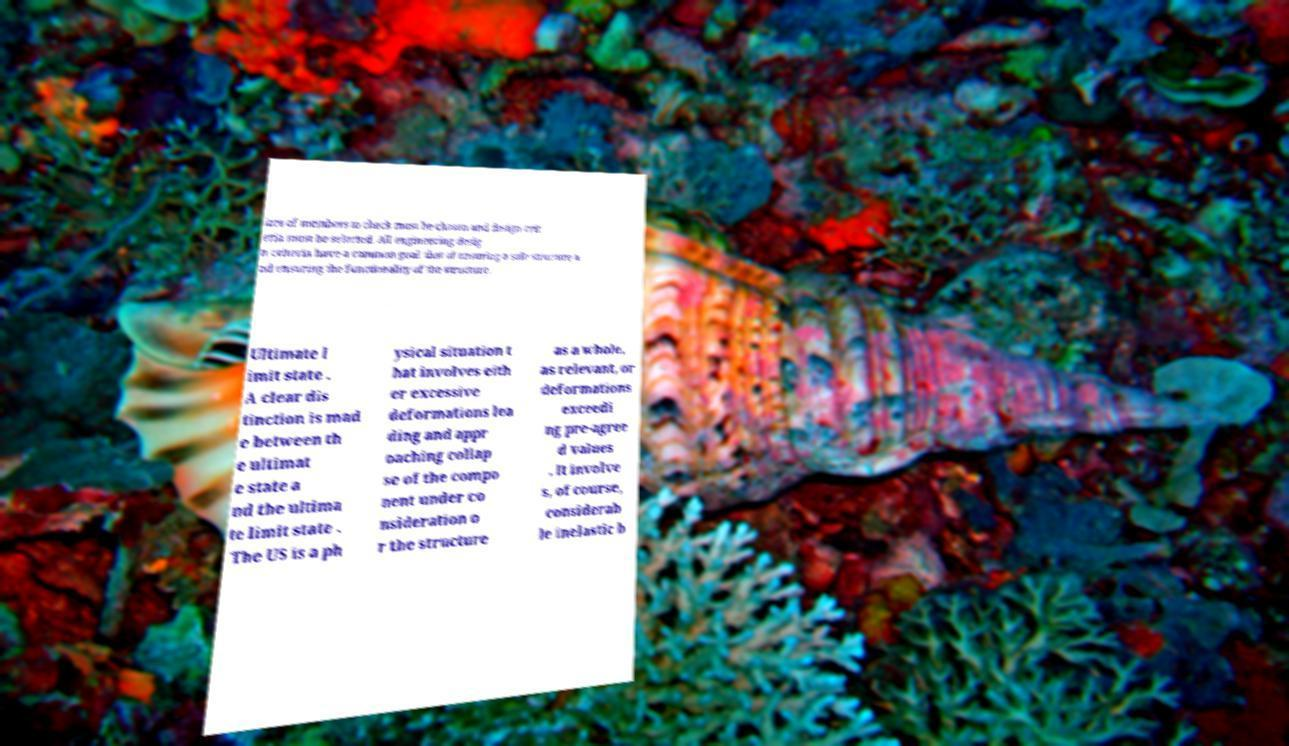There's text embedded in this image that I need extracted. Can you transcribe it verbatim? izes of members to check must be chosen and design crit eria must be selected. All engineering desig n criteria have a common goal: that of ensuring a safe structure a nd ensuring the functionality of the structure. Ultimate l imit state . A clear dis tinction is mad e between th e ultimat e state a nd the ultima te limit state . The US is a ph ysical situation t hat involves eith er excessive deformations lea ding and appr oaching collap se of the compo nent under co nsideration o r the structure as a whole, as relevant, or deformations exceedi ng pre-agree d values . It involve s, of course, considerab le inelastic b 